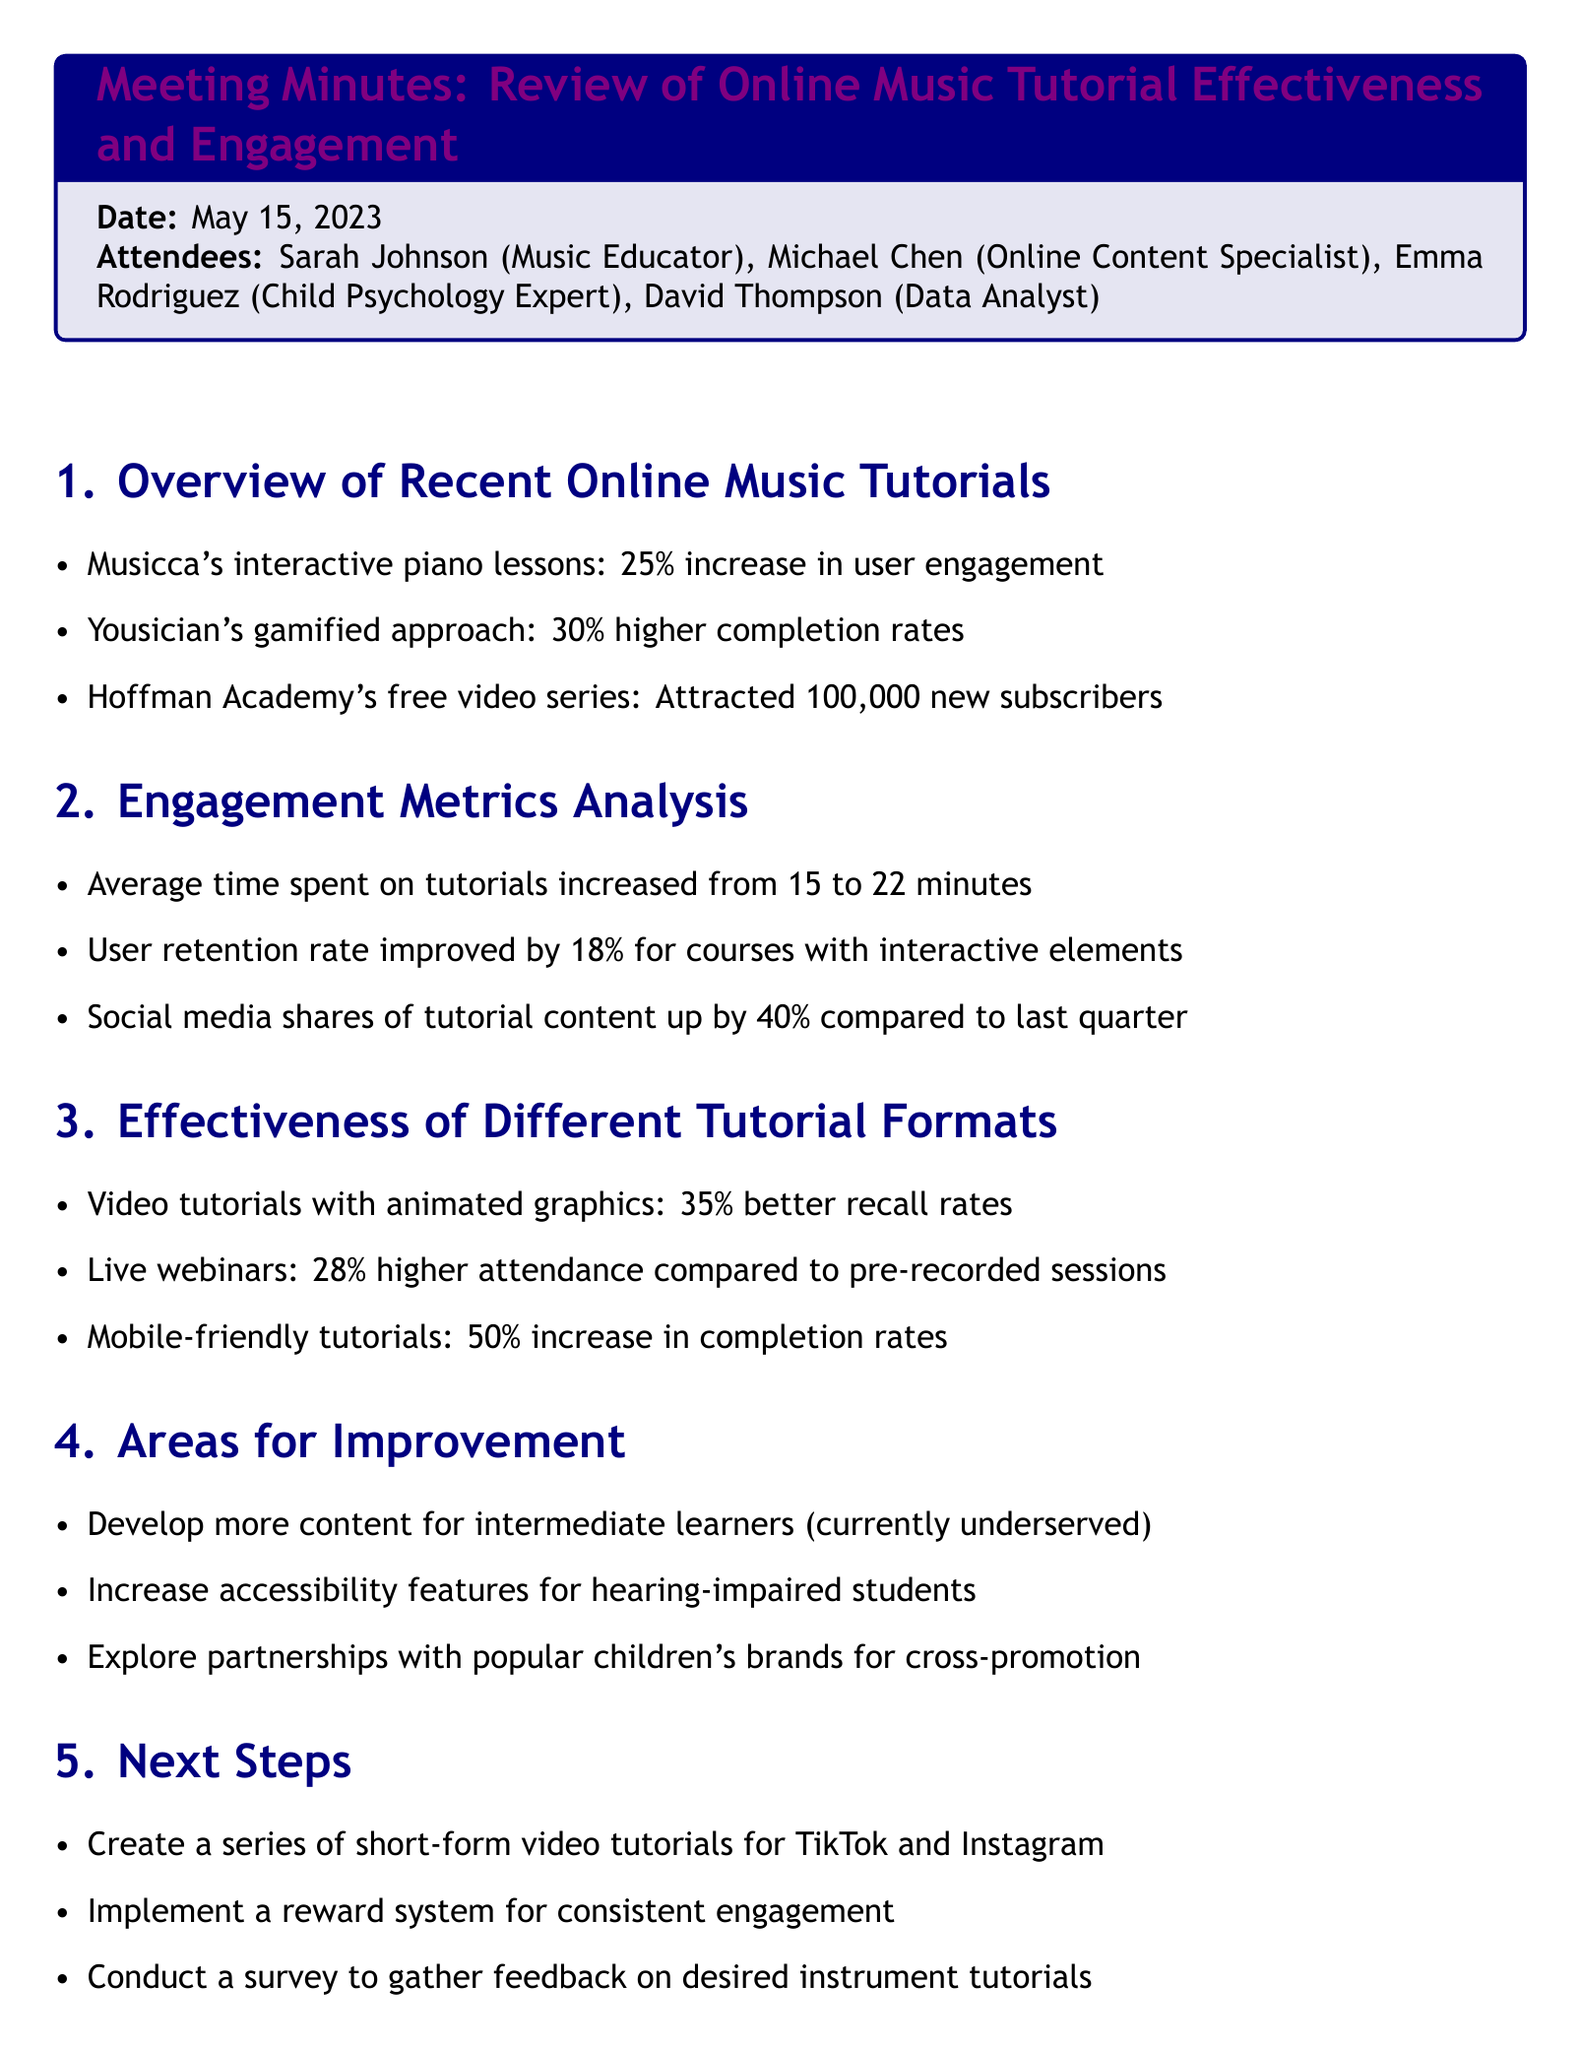What is the date of the meeting? The date of the meeting is explicitly stated at the top of the document.
Answer: May 15, 2023 Who attended the meeting as the Music Educator? The document lists the attendees along with their roles, making it easy to find who attended as the Music Educator.
Answer: Sarah Johnson What was the percentage increase in user engagement for Musicca's interactive piano lessons? The document provides specific statistics for various tutorials, including the engagement increase for Musicca.
Answer: 25% What was the average time spent on tutorials before the increase? The document indicates the average time spent on tutorials and how it changed, allowing for easy comparison.
Answer: 15 minutes What type of tutorials experienced a 50% increase in completion rates? The document categorizes the effectiveness of different tutorial formats, enabling identification of specific types.
Answer: Mobile-friendly tutorials What is one area identified for improvement? The document lists areas for improvement that were discussed in the meeting, giving multiple options to choose from.
Answer: Develop more content for intermediate learners How much did social media shares increase compared to last quarter? The document gives comparative percentages for various engagement metrics, including social media shares.
Answer: 40% What is the next step regarding feedback on desired instrument tutorials? The next steps are clearly outlined in the document, detailing actions the team plans to take.
Answer: Conduct a survey to gather feedback on desired instrument tutorials 